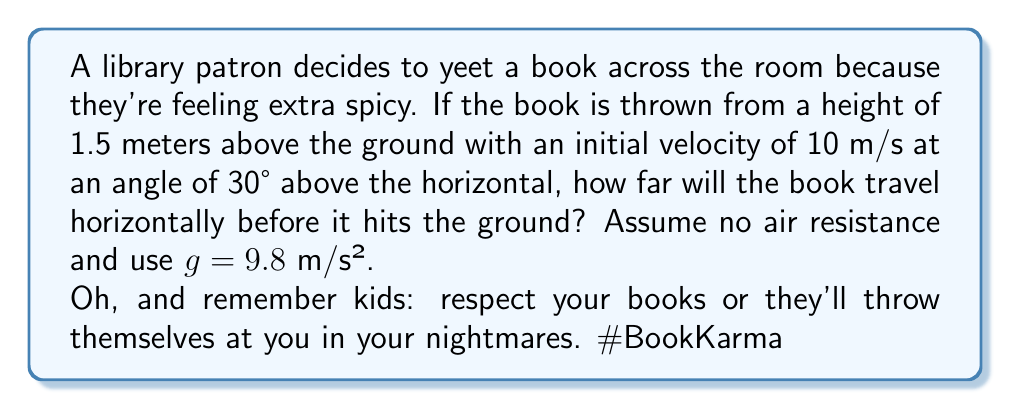Show me your answer to this math problem. Let's break this down step-by-step using projectile motion equations:

1) First, let's identify our known variables:
   - Initial height, $y_0 = 1.5$ m
   - Initial velocity, $v_0 = 10$ m/s
   - Angle of projection, $\theta = 30°$
   - Acceleration due to gravity, $g = 9.8$ m/s²

2) We need to find the time it takes for the book to hit the ground. We can use the vertical motion equation:
   $$y = y_0 + v_0 \sin(\theta)t - \frac{1}{2}gt^2$$

3) At the point of impact, $y = 0$. So we can solve:
   $$0 = 1.5 + 10 \sin(30°)t - \frac{1}{2}(9.8)t^2$$

4) Simplify:
   $$0 = 1.5 + 5t - 4.9t^2$$

5) This is a quadratic equation. We can solve it using the quadratic formula:
   $$t = \frac{-b \pm \sqrt{b^2 - 4ac}}{2a}$$
   where $a = -4.9$, $b = 5$, and $c = 1.5$

6) Solving this gives us two solutions: $t ≈ 0.28$ s and $t ≈ 1.08$ s. We take the positive, larger value as our time of flight.

7) Now that we have the time, we can use the horizontal motion equation to find the distance:
   $$x = v_0 \cos(\theta)t$$

8) Plugging in our values:
   $$x = 10 \cos(30°)(1.08) ≈ 9.35$$ m

Therefore, the book will travel approximately 9.35 meters horizontally before hitting the ground.
Answer: 9.35 m 